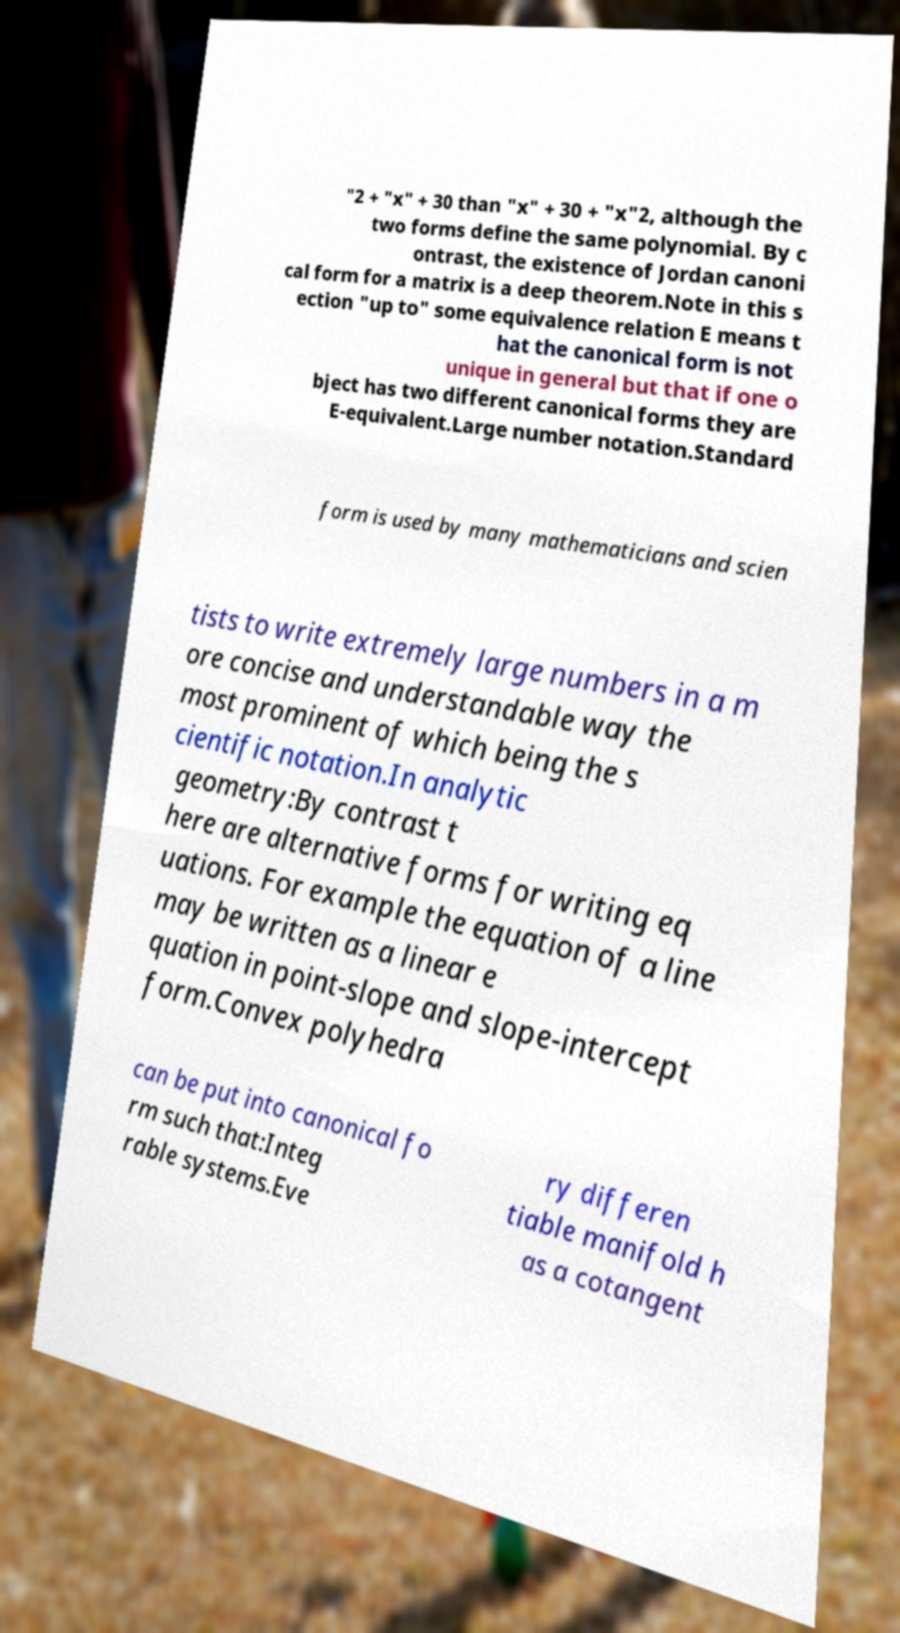Please identify and transcribe the text found in this image. "2 + "x" + 30 than "x" + 30 + "x"2, although the two forms define the same polynomial. By c ontrast, the existence of Jordan canoni cal form for a matrix is a deep theorem.Note in this s ection "up to" some equivalence relation E means t hat the canonical form is not unique in general but that if one o bject has two different canonical forms they are E-equivalent.Large number notation.Standard form is used by many mathematicians and scien tists to write extremely large numbers in a m ore concise and understandable way the most prominent of which being the s cientific notation.In analytic geometry:By contrast t here are alternative forms for writing eq uations. For example the equation of a line may be written as a linear e quation in point-slope and slope-intercept form.Convex polyhedra can be put into canonical fo rm such that:Integ rable systems.Eve ry differen tiable manifold h as a cotangent 